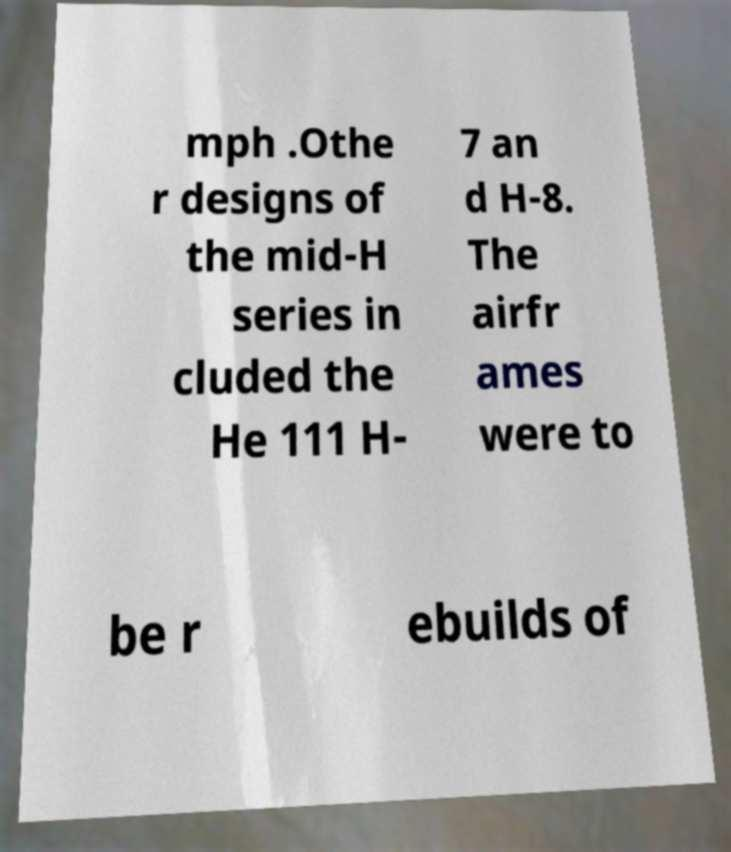There's text embedded in this image that I need extracted. Can you transcribe it verbatim? mph .Othe r designs of the mid-H series in cluded the He 111 H- 7 an d H-8. The airfr ames were to be r ebuilds of 